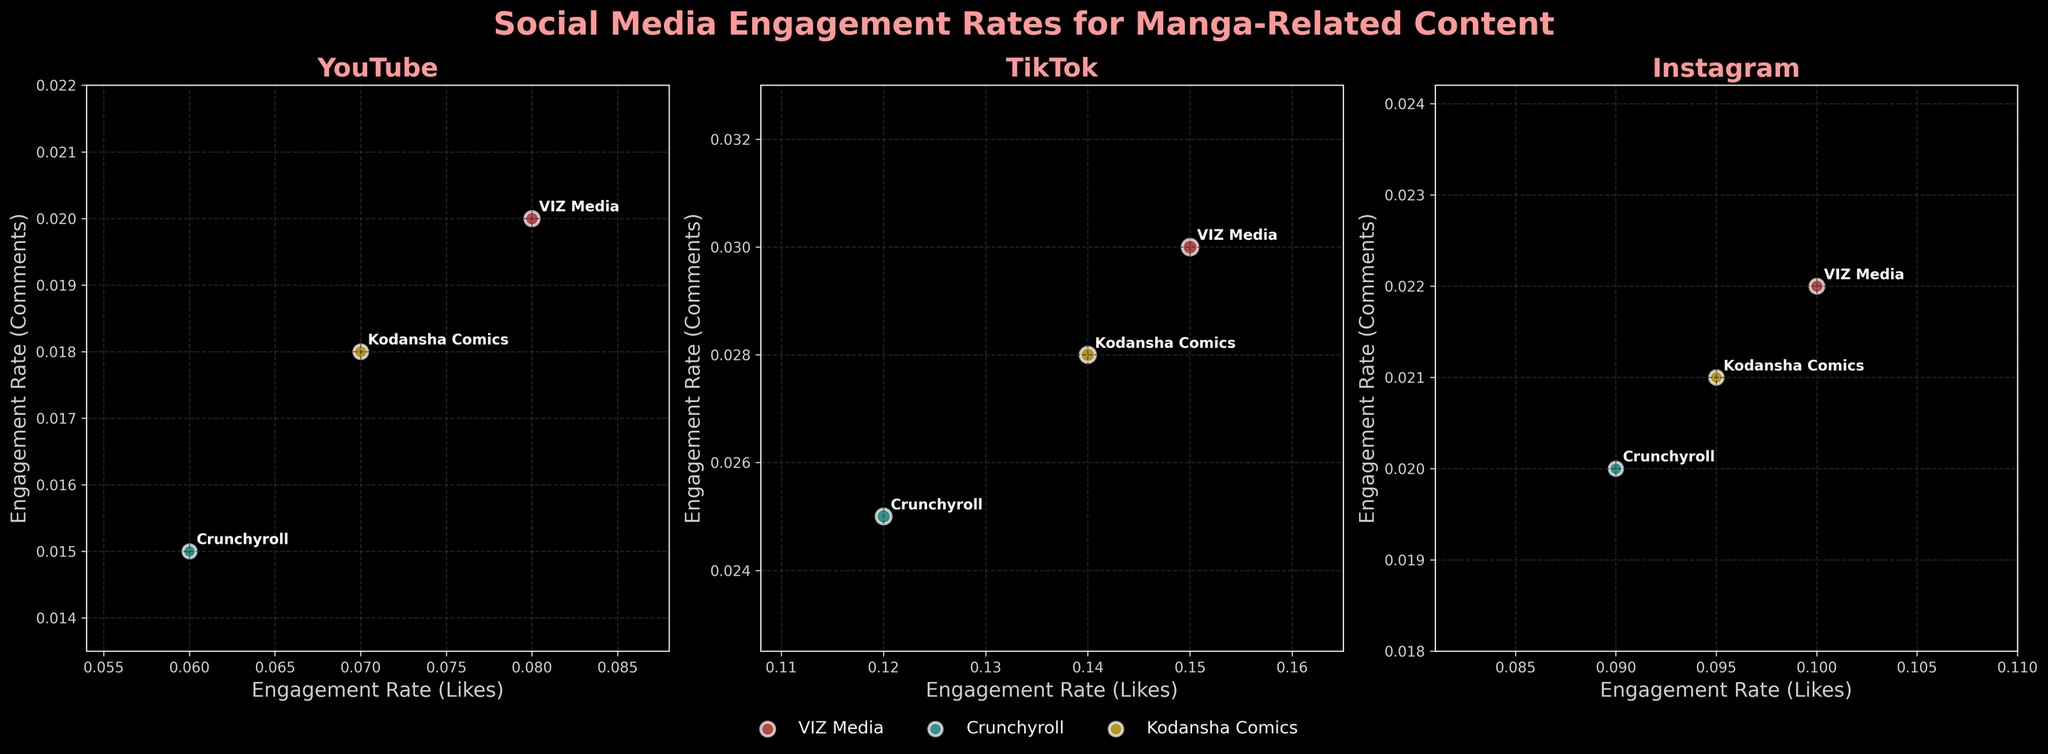What is the title of the figure? The title of the figure is shown at the top and reads, "Social Media Engagement Rates for Manga-Related Content."
Answer: Social Media Engagement Rates for Manga-Related Content How many platforms are analyzed in the figure? There are three subplots, each representing a different platform, so there are three platforms analyzed.
Answer: 3 Which publisher has the largest bubble size on TikTok? By looking at the subplot for TikTok, we can see the largest bubble belongs to VIZ Media.
Answer: VIZ Media What are the x-axis and y-axis labels for the subplots? Each subplot has the same labels: the x-axis is labeled "Engagement Rate (Likes)" and the y-axis is labeled "Engagement Rate (Comments)."
Answer: Engagement Rate (Likes) and Engagement Rate (Comments) Which platform shows the highest engagement rate for likes for VIZ Media? By comparing the highest engagement rates for likes among the subplots, VIZ Media on TikTok has the highest rate at 0.15.
Answer: TikTok Which publisher has the lowest engagement rate for comments on Instagram? By checking the subplot for Instagram, Crunchyroll has the lowest engagement rate for comments at 0.02.
Answer: Crunchyroll Compare the engagement rate for likes between Crunchyroll and Kodansha Comics on YouTube. The subplot for YouTube shows that Crunchyroll has an engagement rate for likes of 0.06, while Kodansha Comics has 0.07, so Kodansha Comics has a higher rate.
Answer: Kodansha Comics Calculate the average engagement rate for comments across all platforms for Kodansha Comics. YouTube: 0.018, TikTok: 0.028, Instagram: 0.021. The average is (0.018 + 0.028 + 0.021) / 3 = 0.0223.
Answer: 0.0223 Which publisher has the highest engagement rate for shares on TikTok? From the TikTok subplot, VIZ Media has the highest engagement rate for shares at 0.04.
Answer: VIZ Media 